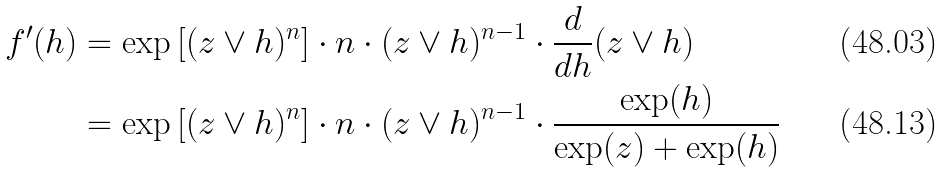<formula> <loc_0><loc_0><loc_500><loc_500>f ^ { \prime } ( h ) & = \exp \left [ ( z \vee h ) ^ { n } \right ] \cdot n \cdot ( z \vee h ) ^ { n - 1 } \cdot \frac { d } { d h } ( z \vee h ) \\ & = \exp \left [ ( z \vee h ) ^ { n } \right ] \cdot n \cdot ( z \vee h ) ^ { n - 1 } \cdot \frac { \exp ( h ) } { \exp ( z ) + \exp ( h ) }</formula> 